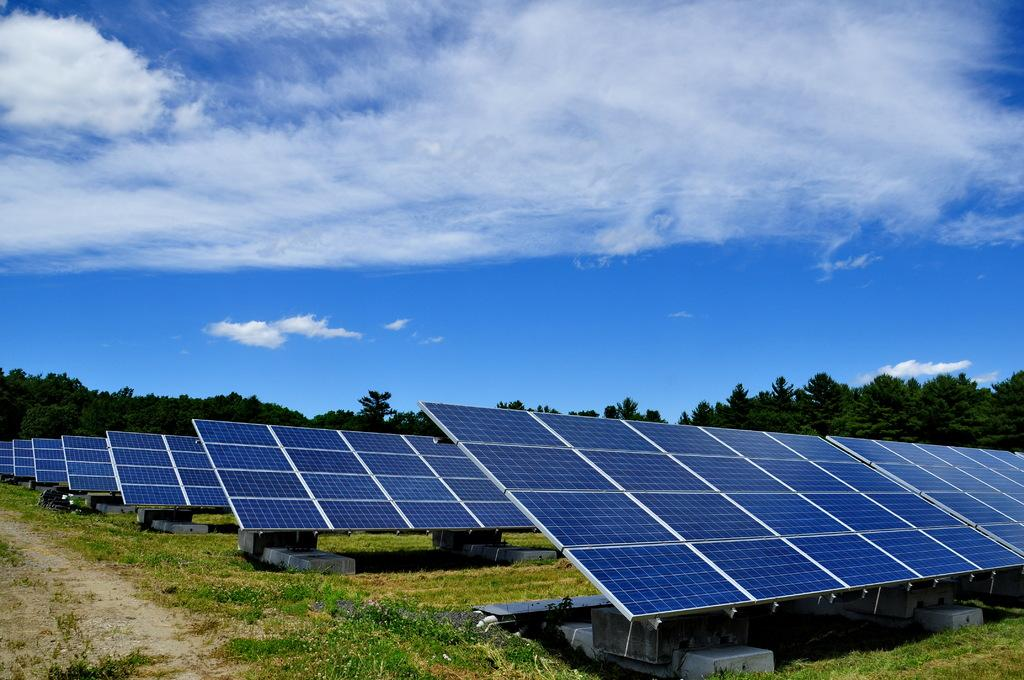What type of objects can be seen in the image? There are some board-like objects in the image. What is at the bottom of the image? There is grass at the bottom of the image. What can be used for walking or traversing in the image? There is a walkway in the image. What type of vegetation is visible in the background of the image? There are trees in the background of the image. What is visible at the top of the image? The sky is visible at the top of the image. Where is the hospital located in the image? There is no hospital present in the image. What type of food is the mom cooking in the image? There is no mom or cooking activity present in the image. 